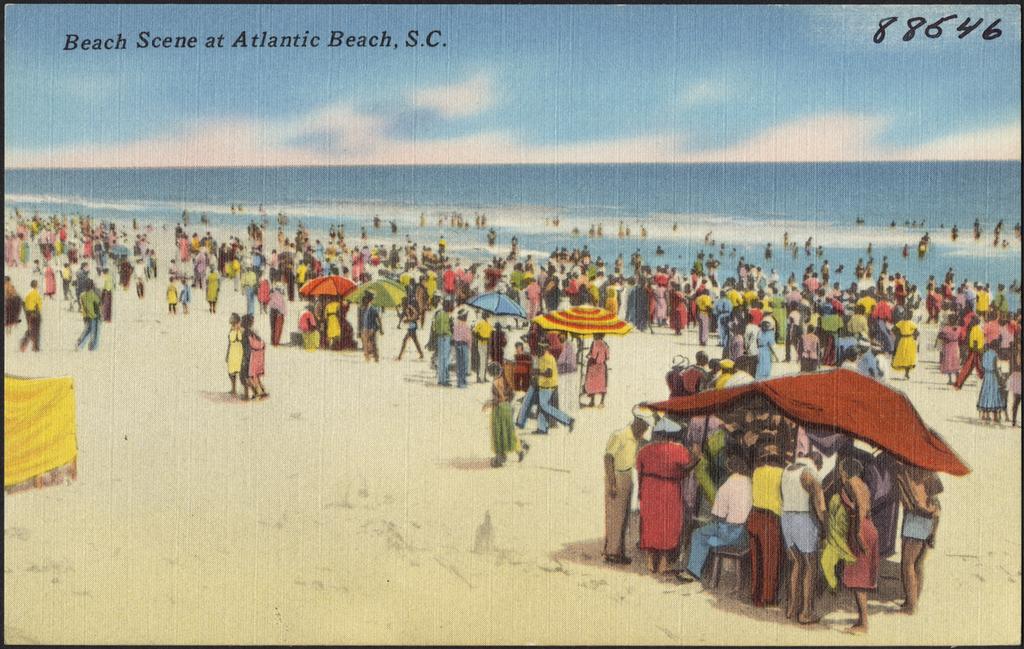What numbers are shown in the top right?
Provide a short and direct response. 88646. 